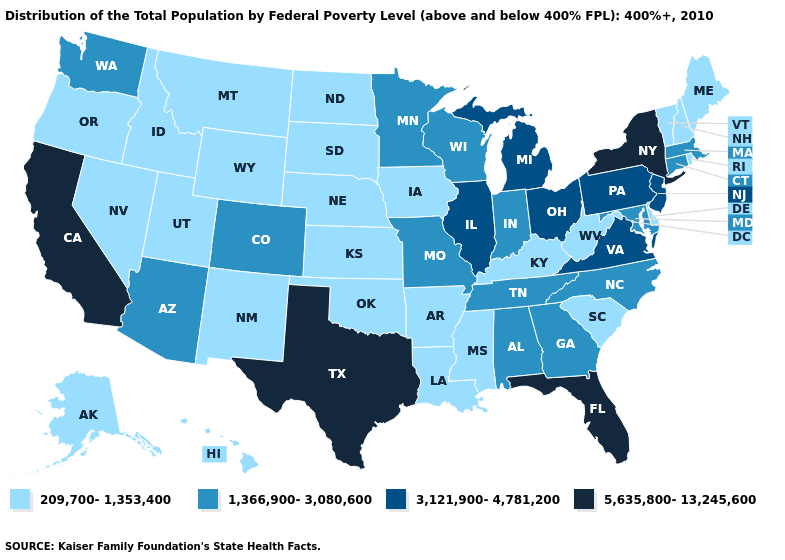Which states have the lowest value in the USA?
Concise answer only. Alaska, Arkansas, Delaware, Hawaii, Idaho, Iowa, Kansas, Kentucky, Louisiana, Maine, Mississippi, Montana, Nebraska, Nevada, New Hampshire, New Mexico, North Dakota, Oklahoma, Oregon, Rhode Island, South Carolina, South Dakota, Utah, Vermont, West Virginia, Wyoming. What is the value of Montana?
Answer briefly. 209,700-1,353,400. What is the value of Delaware?
Concise answer only. 209,700-1,353,400. What is the value of North Dakota?
Answer briefly. 209,700-1,353,400. Name the states that have a value in the range 1,366,900-3,080,600?
Keep it brief. Alabama, Arizona, Colorado, Connecticut, Georgia, Indiana, Maryland, Massachusetts, Minnesota, Missouri, North Carolina, Tennessee, Washington, Wisconsin. Which states have the lowest value in the South?
Give a very brief answer. Arkansas, Delaware, Kentucky, Louisiana, Mississippi, Oklahoma, South Carolina, West Virginia. What is the value of California?
Keep it brief. 5,635,800-13,245,600. Name the states that have a value in the range 209,700-1,353,400?
Concise answer only. Alaska, Arkansas, Delaware, Hawaii, Idaho, Iowa, Kansas, Kentucky, Louisiana, Maine, Mississippi, Montana, Nebraska, Nevada, New Hampshire, New Mexico, North Dakota, Oklahoma, Oregon, Rhode Island, South Carolina, South Dakota, Utah, Vermont, West Virginia, Wyoming. Does California have the highest value in the West?
Concise answer only. Yes. What is the lowest value in the USA?
Be succinct. 209,700-1,353,400. Among the states that border Oregon , does California have the highest value?
Short answer required. Yes. Name the states that have a value in the range 1,366,900-3,080,600?
Give a very brief answer. Alabama, Arizona, Colorado, Connecticut, Georgia, Indiana, Maryland, Massachusetts, Minnesota, Missouri, North Carolina, Tennessee, Washington, Wisconsin. Does Connecticut have the highest value in the USA?
Concise answer only. No. Does Tennessee have the lowest value in the USA?
Write a very short answer. No. Is the legend a continuous bar?
Be succinct. No. 